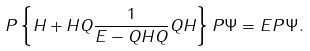<formula> <loc_0><loc_0><loc_500><loc_500>P \left \{ H + H Q \frac { 1 } { E - Q H Q } Q H \right \} P \Psi = E P \Psi .</formula> 